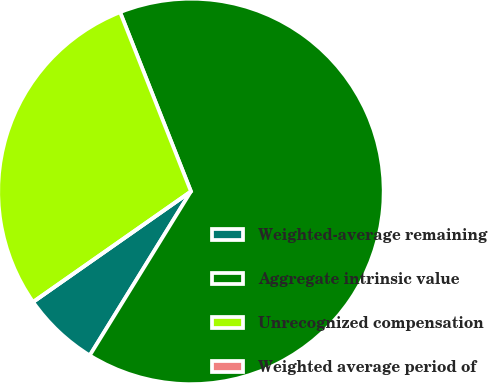Convert chart to OTSL. <chart><loc_0><loc_0><loc_500><loc_500><pie_chart><fcel>Weighted-average remaining<fcel>Aggregate intrinsic value<fcel>Unrecognized compensation<fcel>Weighted average period of<nl><fcel>6.48%<fcel>64.79%<fcel>28.73%<fcel>0.0%<nl></chart> 